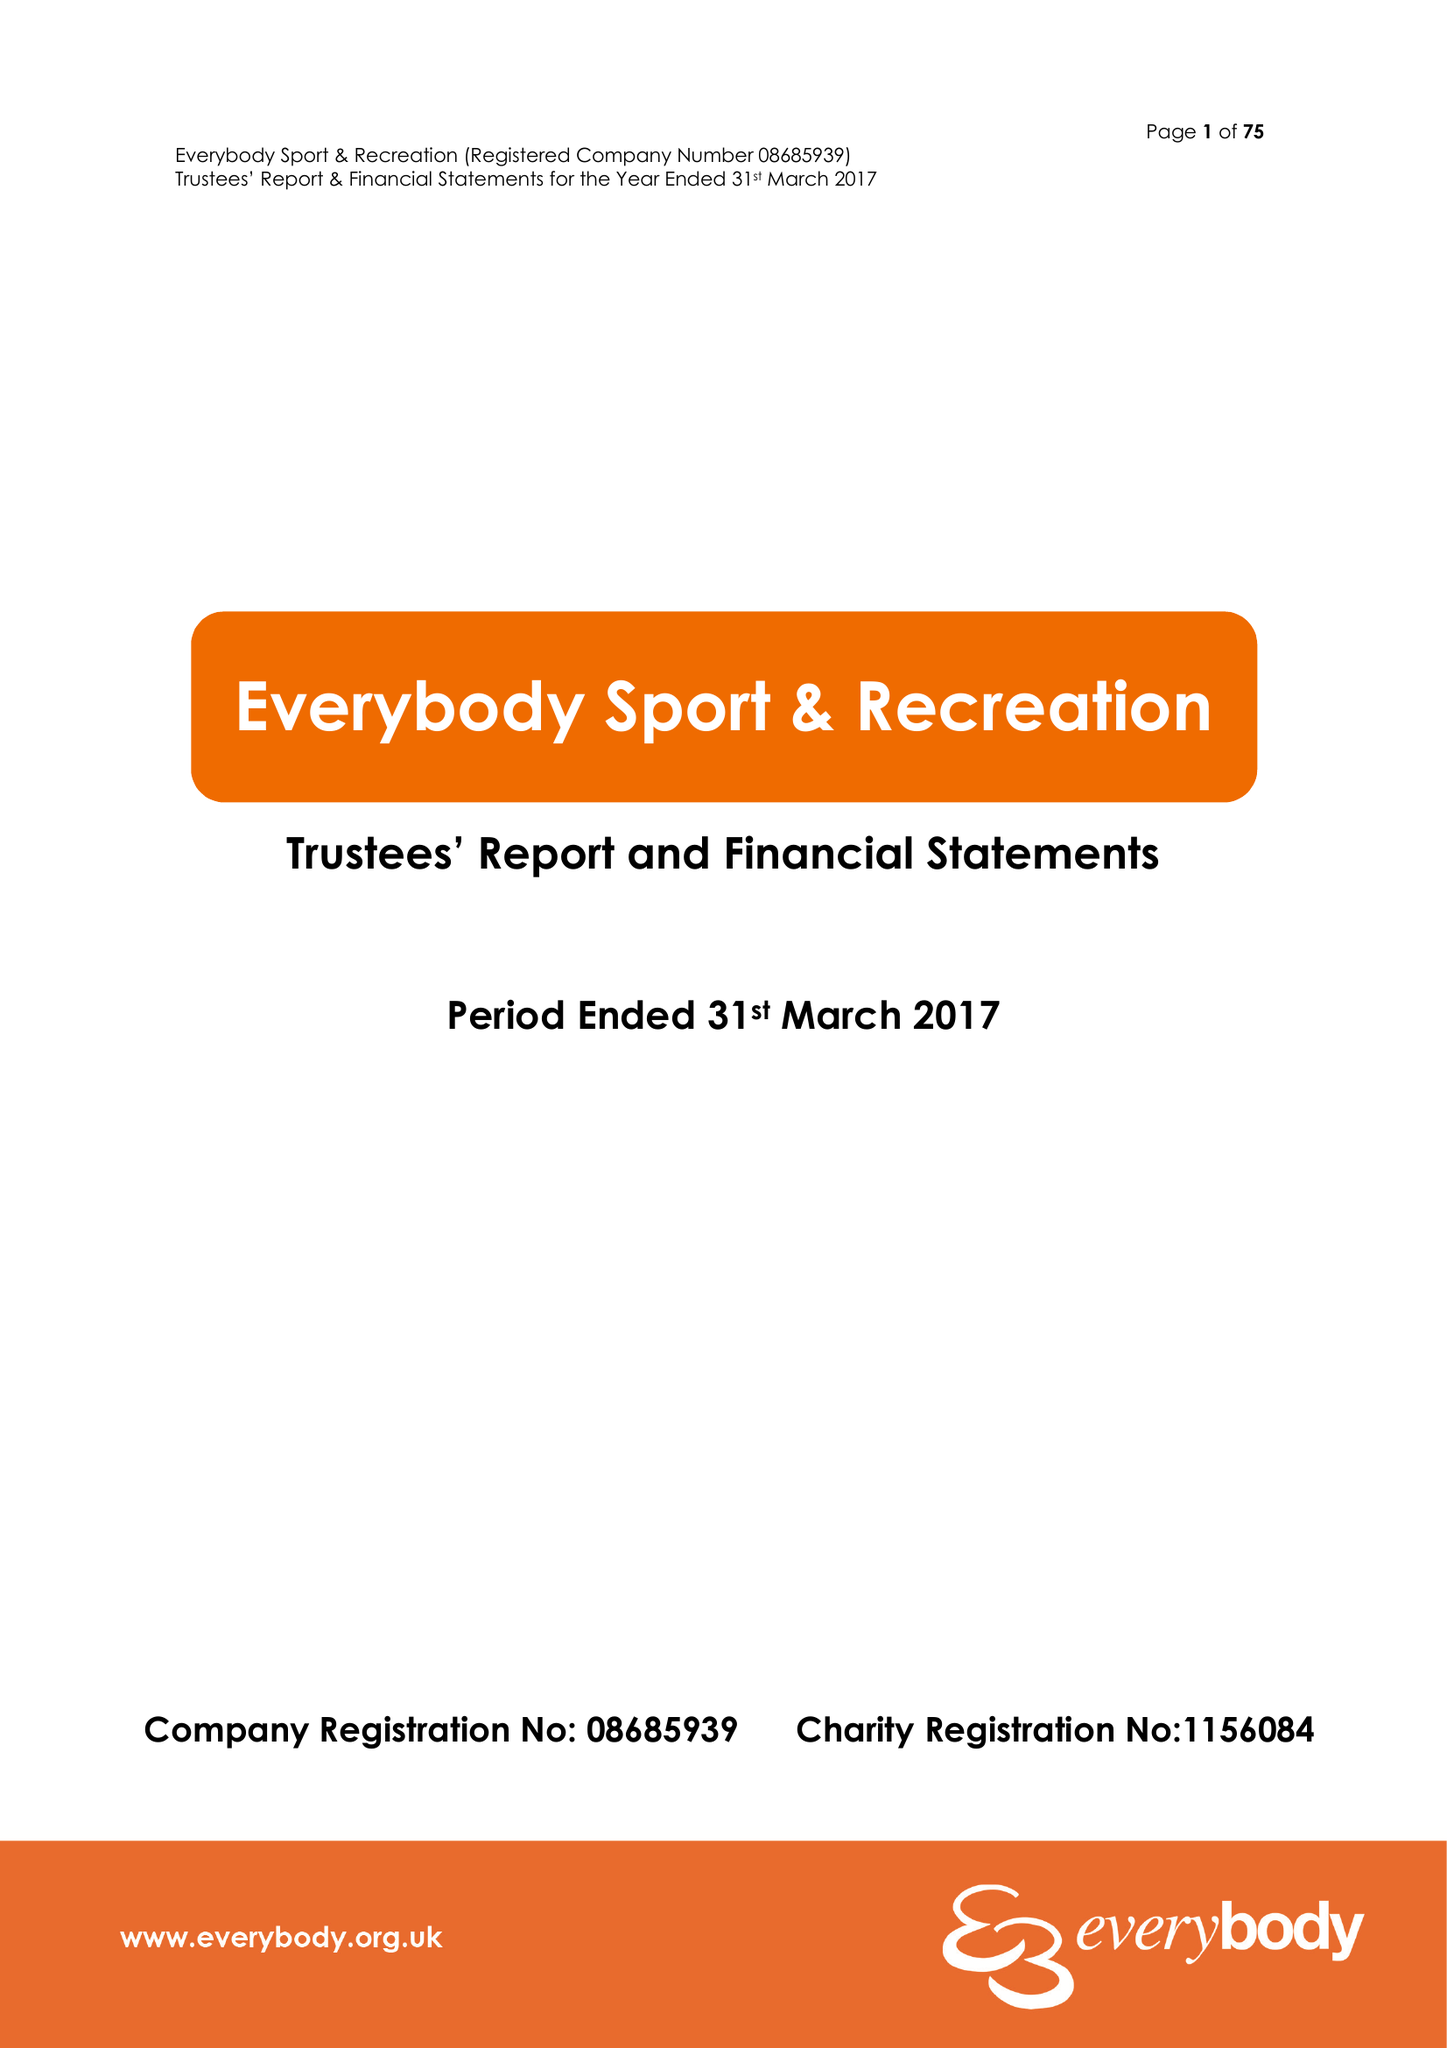What is the value for the address__street_line?
Answer the question using a single word or phrase. STATION ROAD 